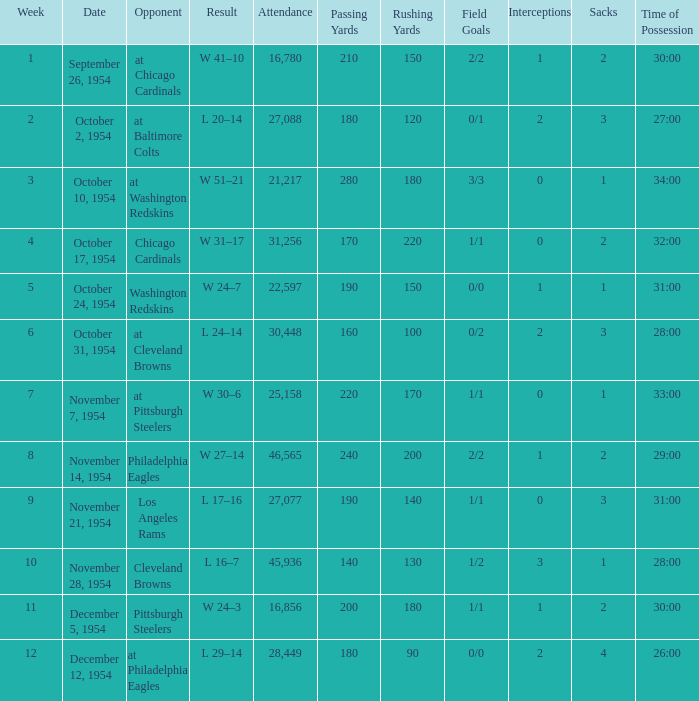How many weeks have october 31, 1954 as the date? 1.0. 